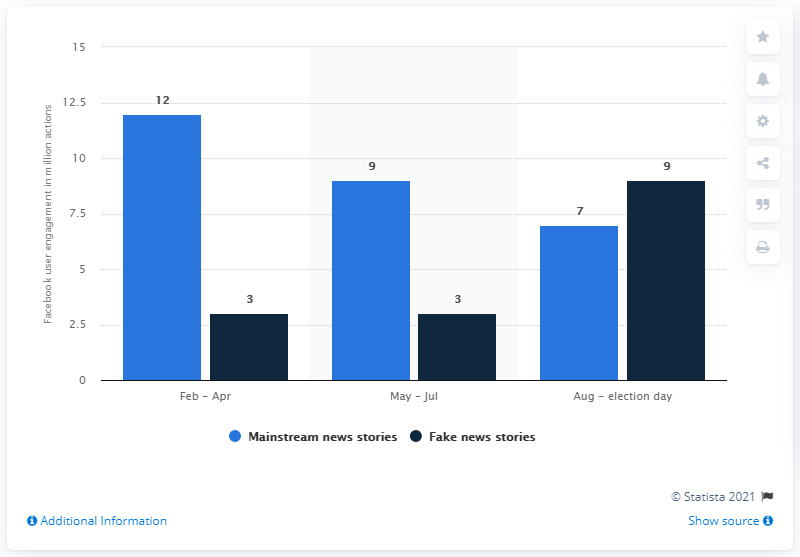Outline some significant characteristics in this image. The number of actions that mainstream news stories generated on Facebook from February to April 2016 was 12. In August and up to Election Day, fake news generated approximately 9 Facebook actions. In the period of February to April 2016, fake news generated a total of 3 actions on Facebook. 